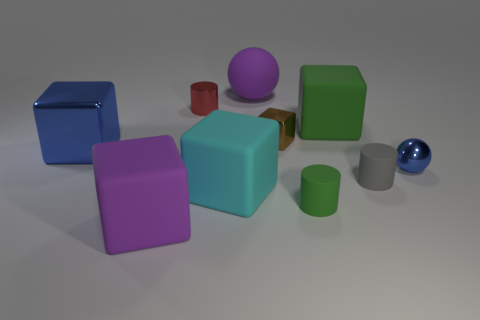Subtract all purple matte cubes. How many cubes are left? 4 Subtract 2 cubes. How many cubes are left? 3 Subtract all green blocks. How many blocks are left? 4 Subtract all blue cylinders. Subtract all red balls. How many cylinders are left? 3 Subtract all cylinders. How many objects are left? 7 Subtract all small red objects. Subtract all large blue cubes. How many objects are left? 8 Add 5 big green rubber things. How many big green rubber things are left? 6 Add 7 tiny brown matte cubes. How many tiny brown matte cubes exist? 7 Subtract 0 yellow spheres. How many objects are left? 10 